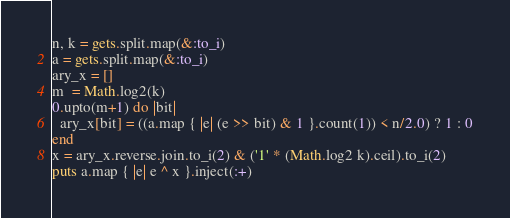Convert code to text. <code><loc_0><loc_0><loc_500><loc_500><_Ruby_>n, k = gets.split.map(&:to_i)
a = gets.split.map(&:to_i)
ary_x = []
m  = Math.log2(k)
0.upto(m+1) do |bit|
  ary_x[bit] = ((a.map { |e| (e >> bit) & 1 }.count(1)) < n/2.0) ? 1 : 0
end
x = ary_x.reverse.join.to_i(2) & ('1' * (Math.log2 k).ceil).to_i(2)
puts a.map { |e| e ^ x }.inject(:+)
</code> 